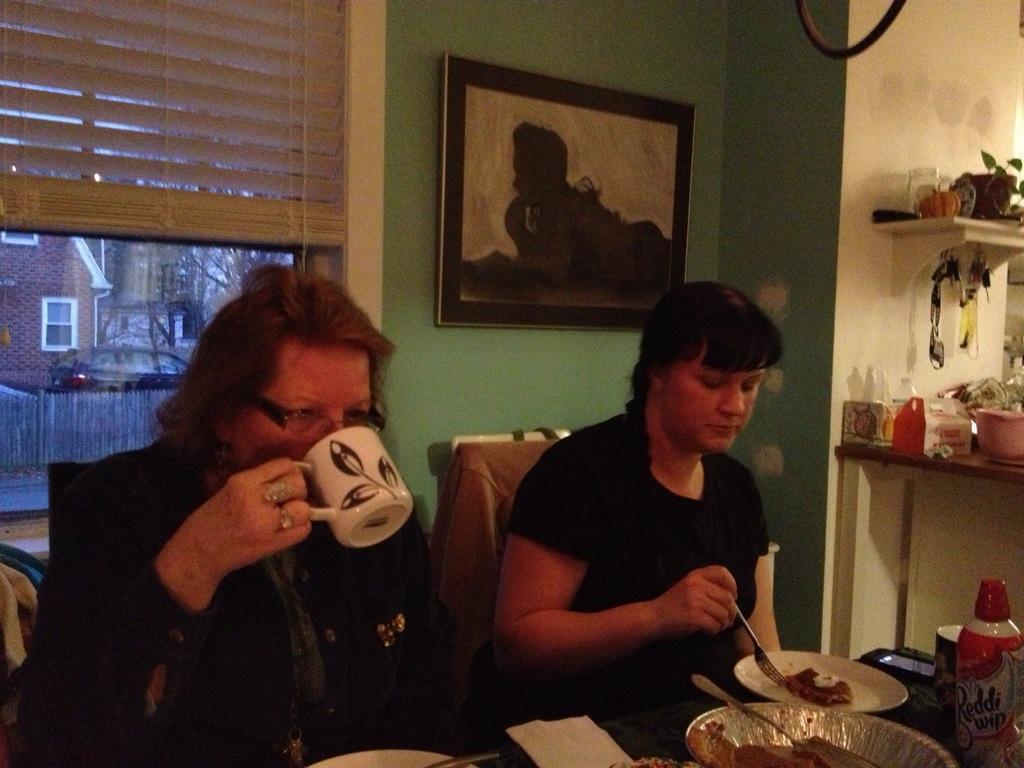Please provide a concise description of this image. In this image, I can see two women sitting on the chairs. This is the table with plates, cup, mobile phone, tissue paper, bottle and few other things on it. This plate contains some food. This woman is holding a cup and drinking. I can see the photo frame attached to the wall. This is the window with a curtain. I can see the rack, which is attached to the wall. This another table with few objects on it. I can see a house with a window, a car and a wooden fence through the window. 